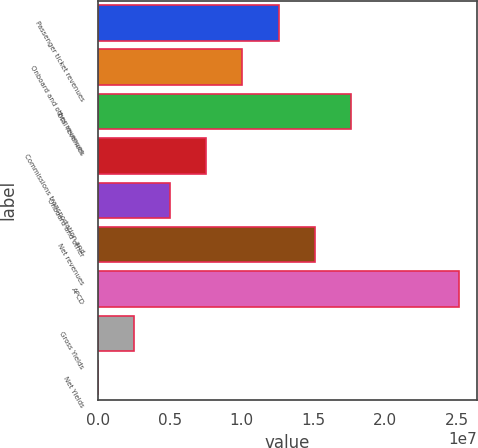<chart> <loc_0><loc_0><loc_500><loc_500><bar_chart><fcel>Passenger ticket revenues<fcel>Onboard and other revenues<fcel>Total revenues<fcel>Commissions transportation and<fcel>Onboard and other<fcel>Net revenues<fcel>APCD<fcel>Gross Yields<fcel>Net Yields<nl><fcel>1.2578e+07<fcel>1.00624e+07<fcel>1.76091e+07<fcel>7.54686e+06<fcel>5.0313e+06<fcel>1.50935e+07<fcel>2.51558e+07<fcel>2.51574e+06<fcel>183.64<nl></chart> 